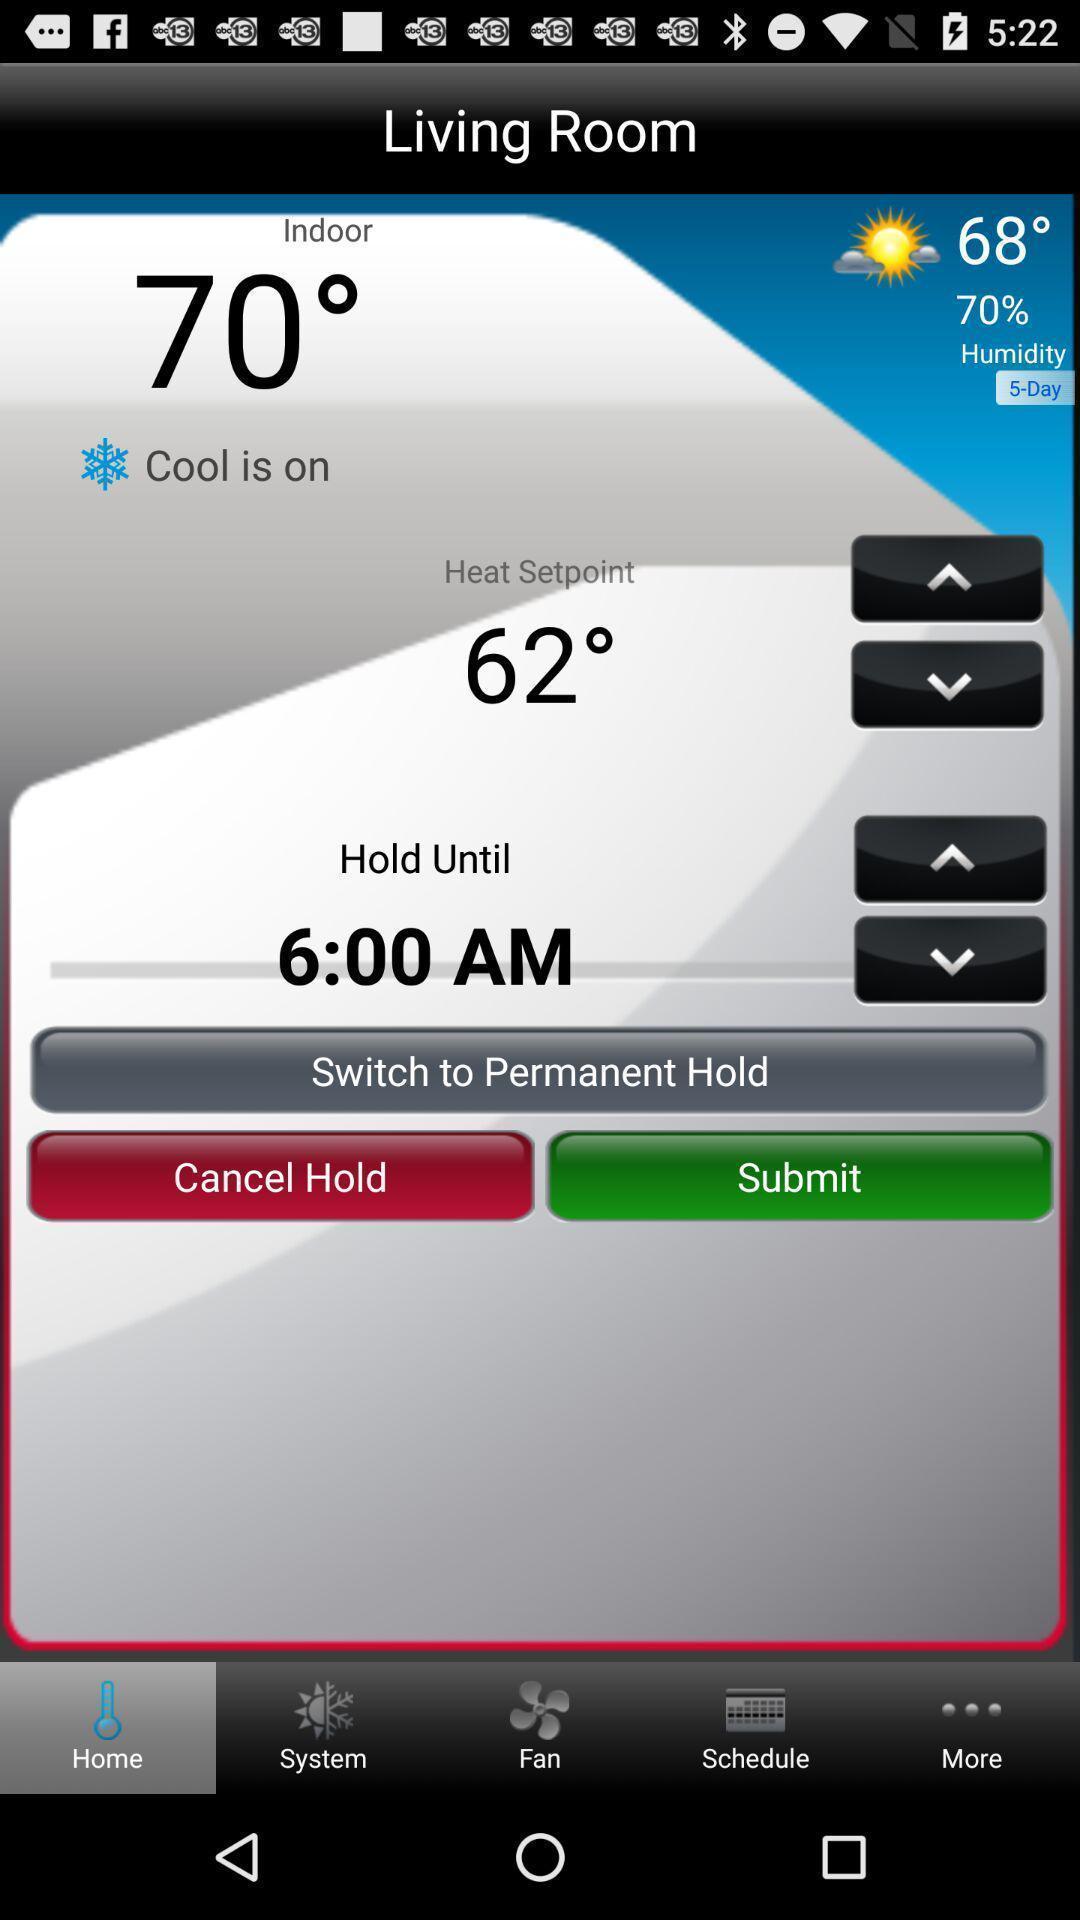Provide a textual representation of this image. Social app showing weather report. 